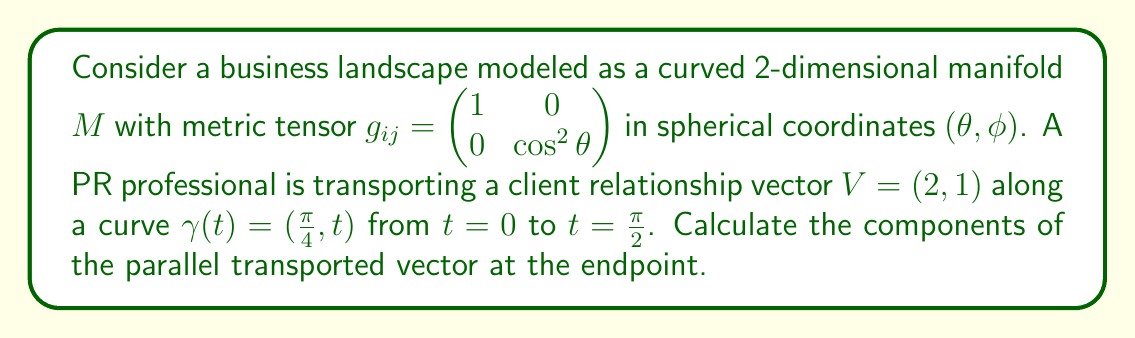Can you answer this question? To solve this problem, we'll follow these steps:

1) First, we need to calculate the Christoffel symbols for this metric. The non-zero symbols are:

   $$\Gamma^2_{12} = \Gamma^2_{21} = \tan \theta$$

2) The parallel transport equation is:

   $$\frac{dV^i}{dt} + \Gamma^i_{jk} \frac{d\gamma^j}{dt} V^k = 0$$

3) For our curve $\gamma(t) = (\frac{\pi}{4}, t)$, we have $\frac{d\gamma^1}{dt} = 0$ and $\frac{d\gamma^2}{dt} = 1$

4) Expanding the parallel transport equation:

   For $i = 1$: $\frac{dV^1}{dt} = 0$
   For $i = 2$: $\frac{dV^2}{dt} + \tan(\frac{\pi}{4}) V^2 = 0$

5) Solving these equations:

   $V^1(t) = 2$ (constant)
   $V^2(t) = C e^{-t\tan(\frac{\pi}{4})}$

6) Using the initial condition $V^2(0) = 1$, we find $C = 1$

7) At $t = \frac{\pi}{2}$, the components of the parallel transported vector are:

   $V^1(\frac{\pi}{2}) = 2$
   $V^2(\frac{\pi}{2}) = e^{-\frac{\pi}{2}\tan(\frac{\pi}{4})} \approx 0.2075$
Answer: $(2, 0.2075)$ 